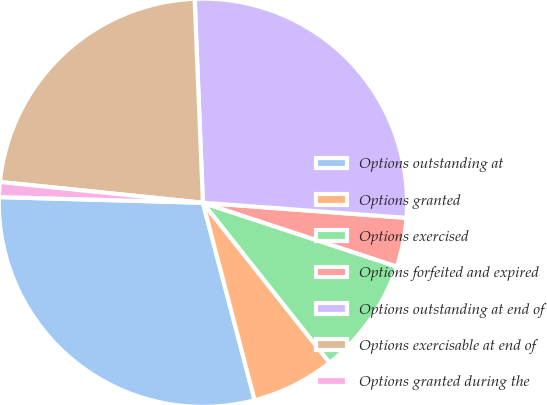Convert chart. <chart><loc_0><loc_0><loc_500><loc_500><pie_chart><fcel>Options outstanding at<fcel>Options granted<fcel>Options exercised<fcel>Options forfeited and expired<fcel>Options outstanding at end of<fcel>Options exercisable at end of<fcel>Options granted during the<nl><fcel>29.52%<fcel>6.58%<fcel>9.28%<fcel>3.88%<fcel>26.82%<fcel>22.73%<fcel>1.18%<nl></chart> 